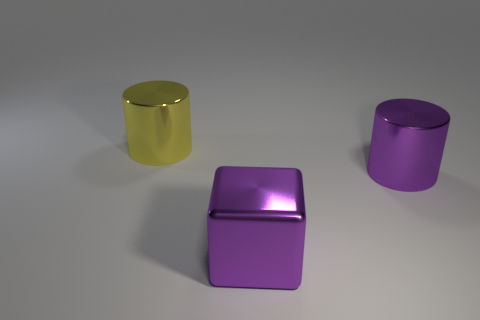What shape is the object that is the same color as the metal cube?
Provide a succinct answer. Cylinder. What is the size of the cylinder that is in front of the metallic object to the left of the metal cube?
Your response must be concise. Large. Are there any gray cubes of the same size as the purple metallic cube?
Make the answer very short. No. Does the metallic cylinder that is on the right side of the yellow shiny cylinder have the same size as the cylinder to the left of the metal block?
Provide a succinct answer. Yes. There is a large purple metal thing that is in front of the shiny thing that is to the right of the metallic block; what is its shape?
Provide a succinct answer. Cube. How many metal things are behind the purple metallic cylinder?
Your answer should be very brief. 1. There is another large cylinder that is the same material as the big purple cylinder; what is its color?
Your answer should be compact. Yellow. There is a purple cylinder; is its size the same as the cylinder on the left side of the purple metallic block?
Your answer should be compact. Yes. There is a thing to the right of the big purple thing that is in front of the metal cylinder that is in front of the large yellow cylinder; how big is it?
Make the answer very short. Large. What number of metal things are either yellow objects or purple cylinders?
Provide a short and direct response. 2. 